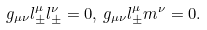Convert formula to latex. <formula><loc_0><loc_0><loc_500><loc_500>g _ { \mu \nu } l ^ { \mu } _ { \pm } l ^ { \nu } _ { \pm } = 0 , \, g _ { \mu \nu } l ^ { \mu } _ { \pm } m ^ { \nu } = 0 .</formula> 